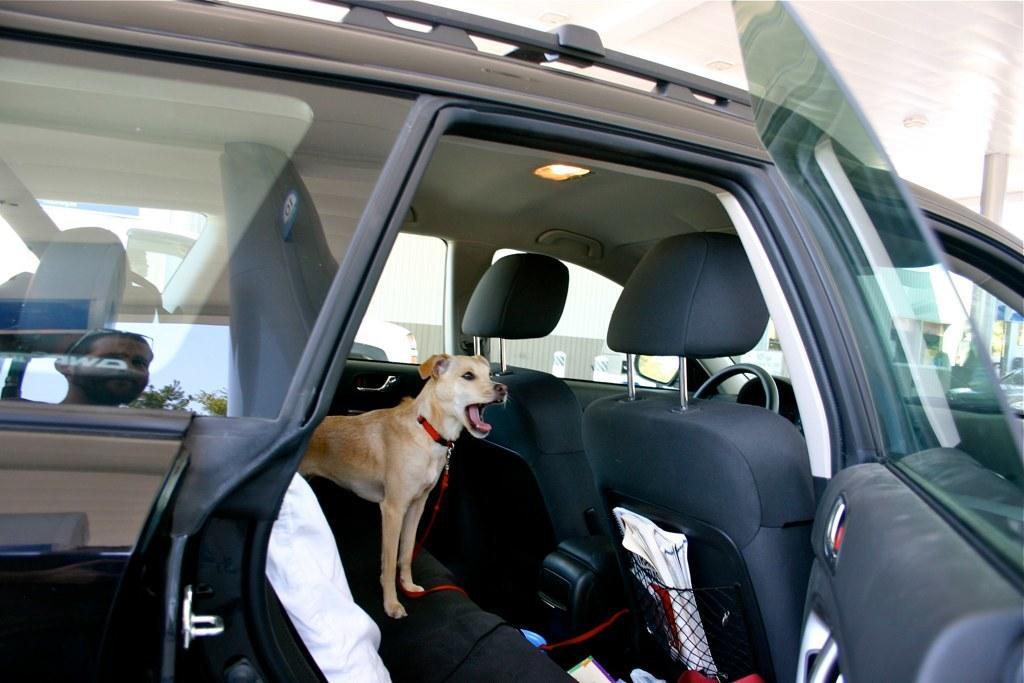Please provide a concise description of this image. This picture is mainly highlighted with a car. Inside the car we can see a dog in brown colour and with opening mouth. Through car glass window we can see outside view and here we can see the reflection of a person and a tree on car glass window. 